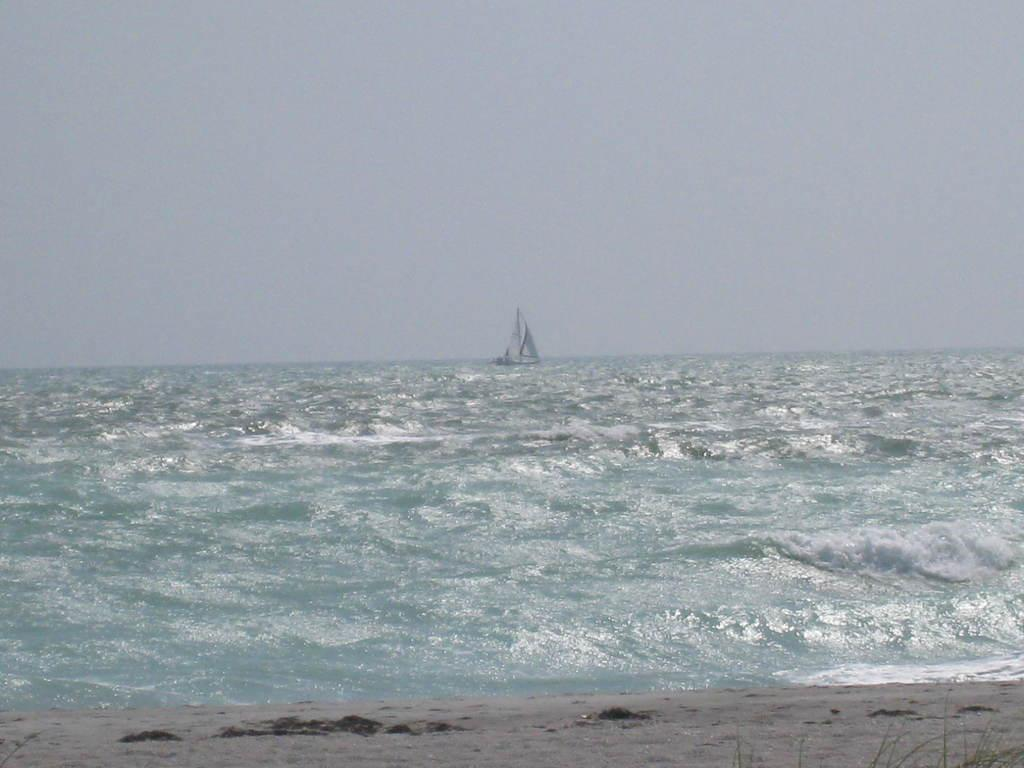What is the main feature in the center of the image? There is a river in the center of the image. What is located in the river? There is a boat in the river. What type of terrain is visible at the bottom of the image? There is sand at the bottom of the image. What is visible at the top of the image? The sky is visible at the top of the image. What month is it in the image? The image does not provide any information about the month or time of year. Can you see any worms or snails in the image? There are no worms or snails visible in the image. 